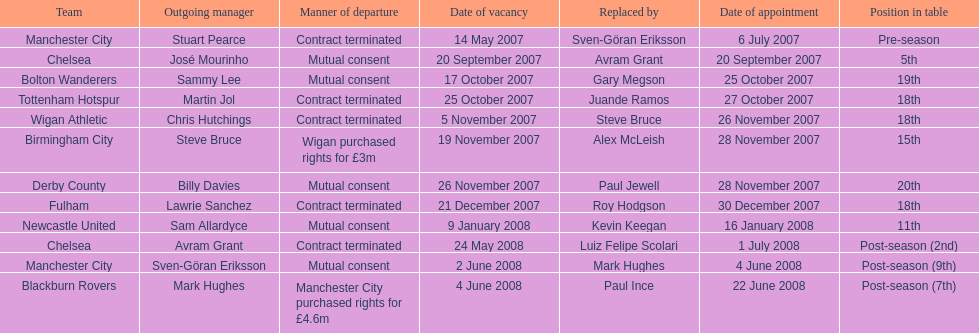What was the top team according to position in table called? Manchester City. 